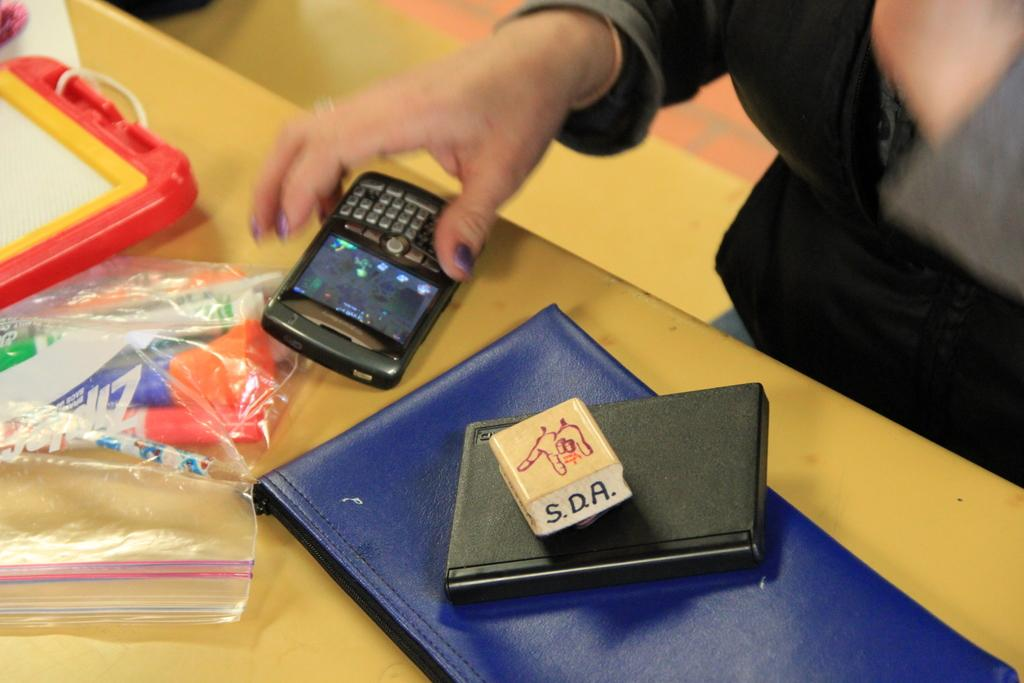<image>
Give a short and clear explanation of the subsequent image. A person places their Blackberry phone down next to a Ziploc bag and a pile of books. 